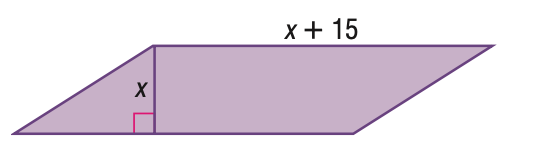Answer the mathemtical geometry problem and directly provide the correct option letter.
Question: Find the height of the parallelogram given its area with 100 square units.
Choices: A: 5 B: 10 C: 15 D: 20 A 